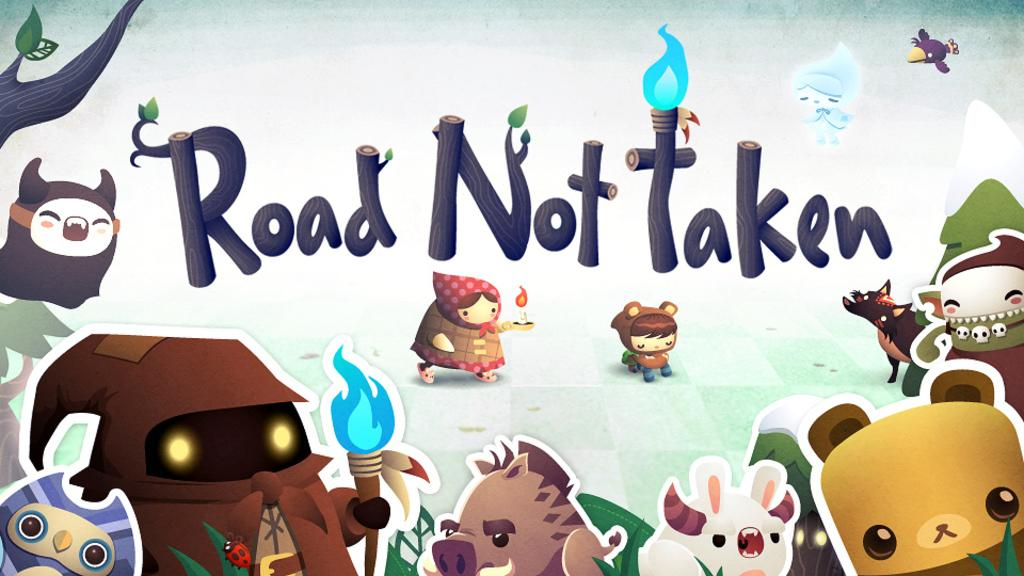What type of visual is the image in question? The image is a poster. What kind of images can be seen on the poster? There are cartoon images on the poster. What natural elements are depicted on the poster? There are trees depicted on the poster. What objects are present on the poster? Wooden sticks are present on the poster. Where is the shelf located in the poster? There is no shelf present in the poster. What type of ghost can be seen interacting with the wooden sticks in the poster? There are no ghosts depicted in the poster; it features cartoon images and trees. 